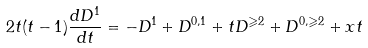Convert formula to latex. <formula><loc_0><loc_0><loc_500><loc_500>2 t ( t - 1 ) \frac { d D ^ { 1 } } { d t } = - D ^ { 1 } + D ^ { 0 , 1 } + t D ^ { \geqslant 2 } + D ^ { 0 , \geqslant 2 } + x t</formula> 